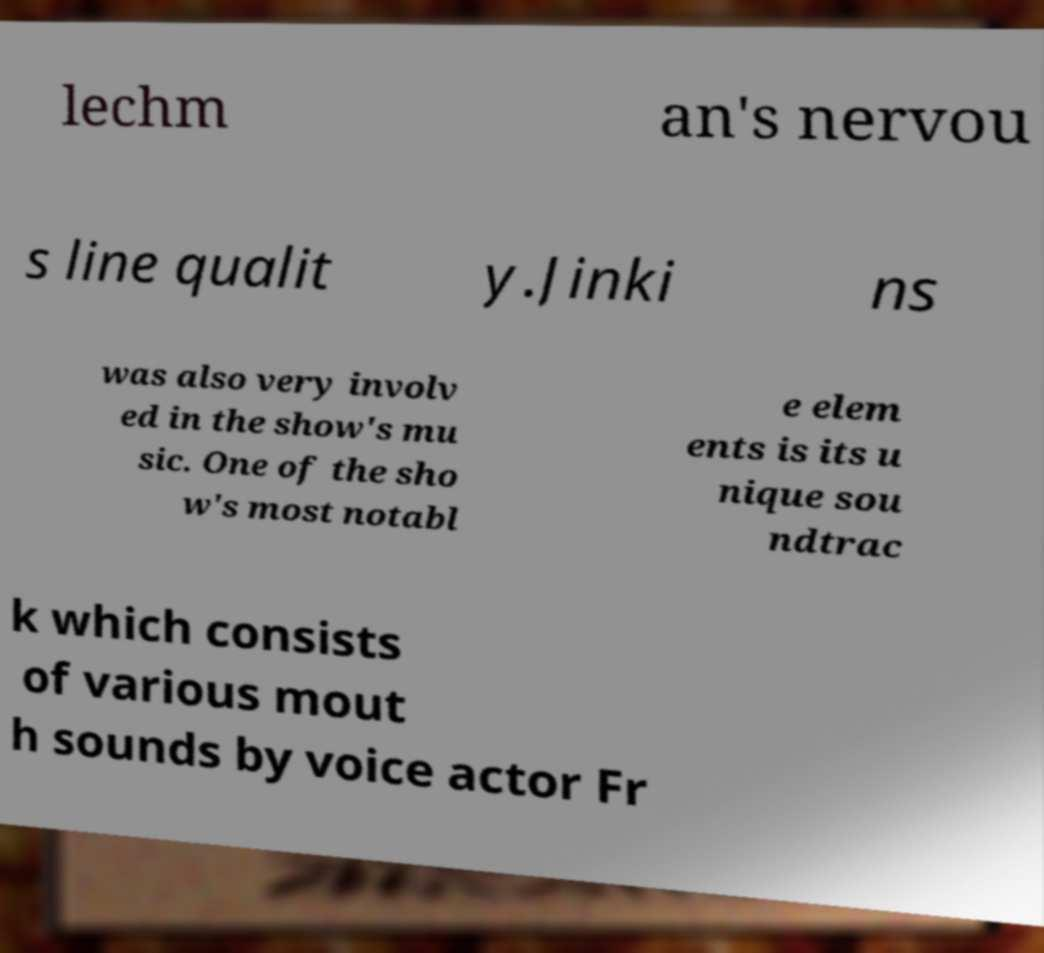Could you assist in decoding the text presented in this image and type it out clearly? lechm an's nervou s line qualit y.Jinki ns was also very involv ed in the show's mu sic. One of the sho w's most notabl e elem ents is its u nique sou ndtrac k which consists of various mout h sounds by voice actor Fr 